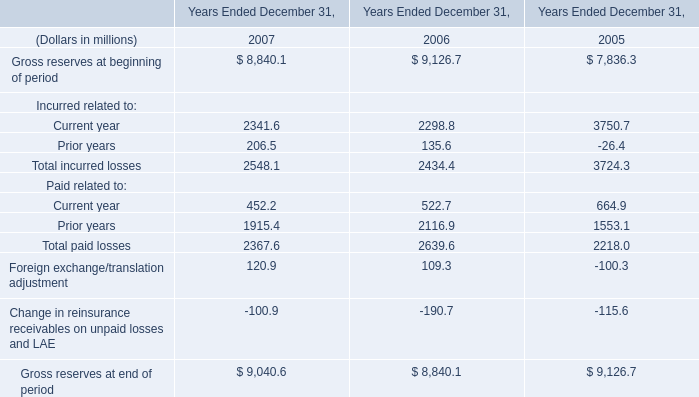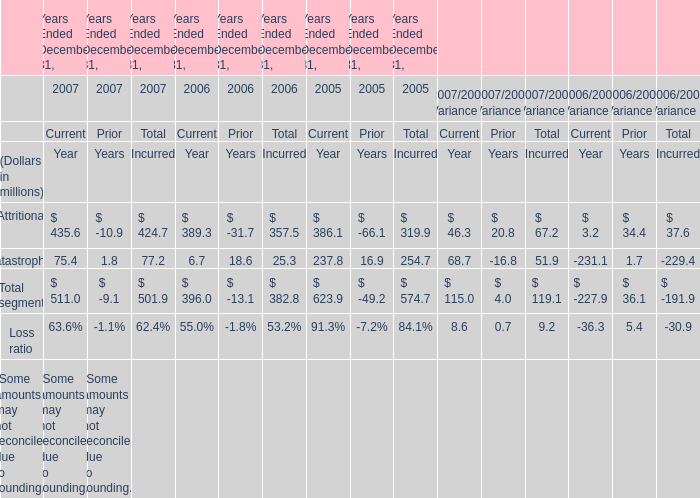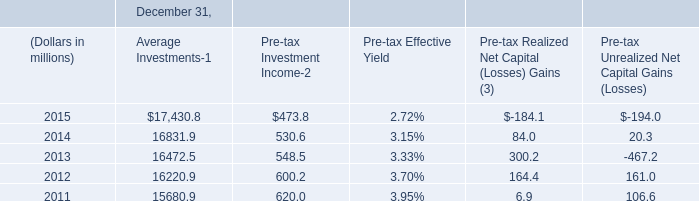what is the book to market ratio of the commercial mortgage-backed securities 
Computations: (264.9 / 266.3)
Answer: 0.99474. 